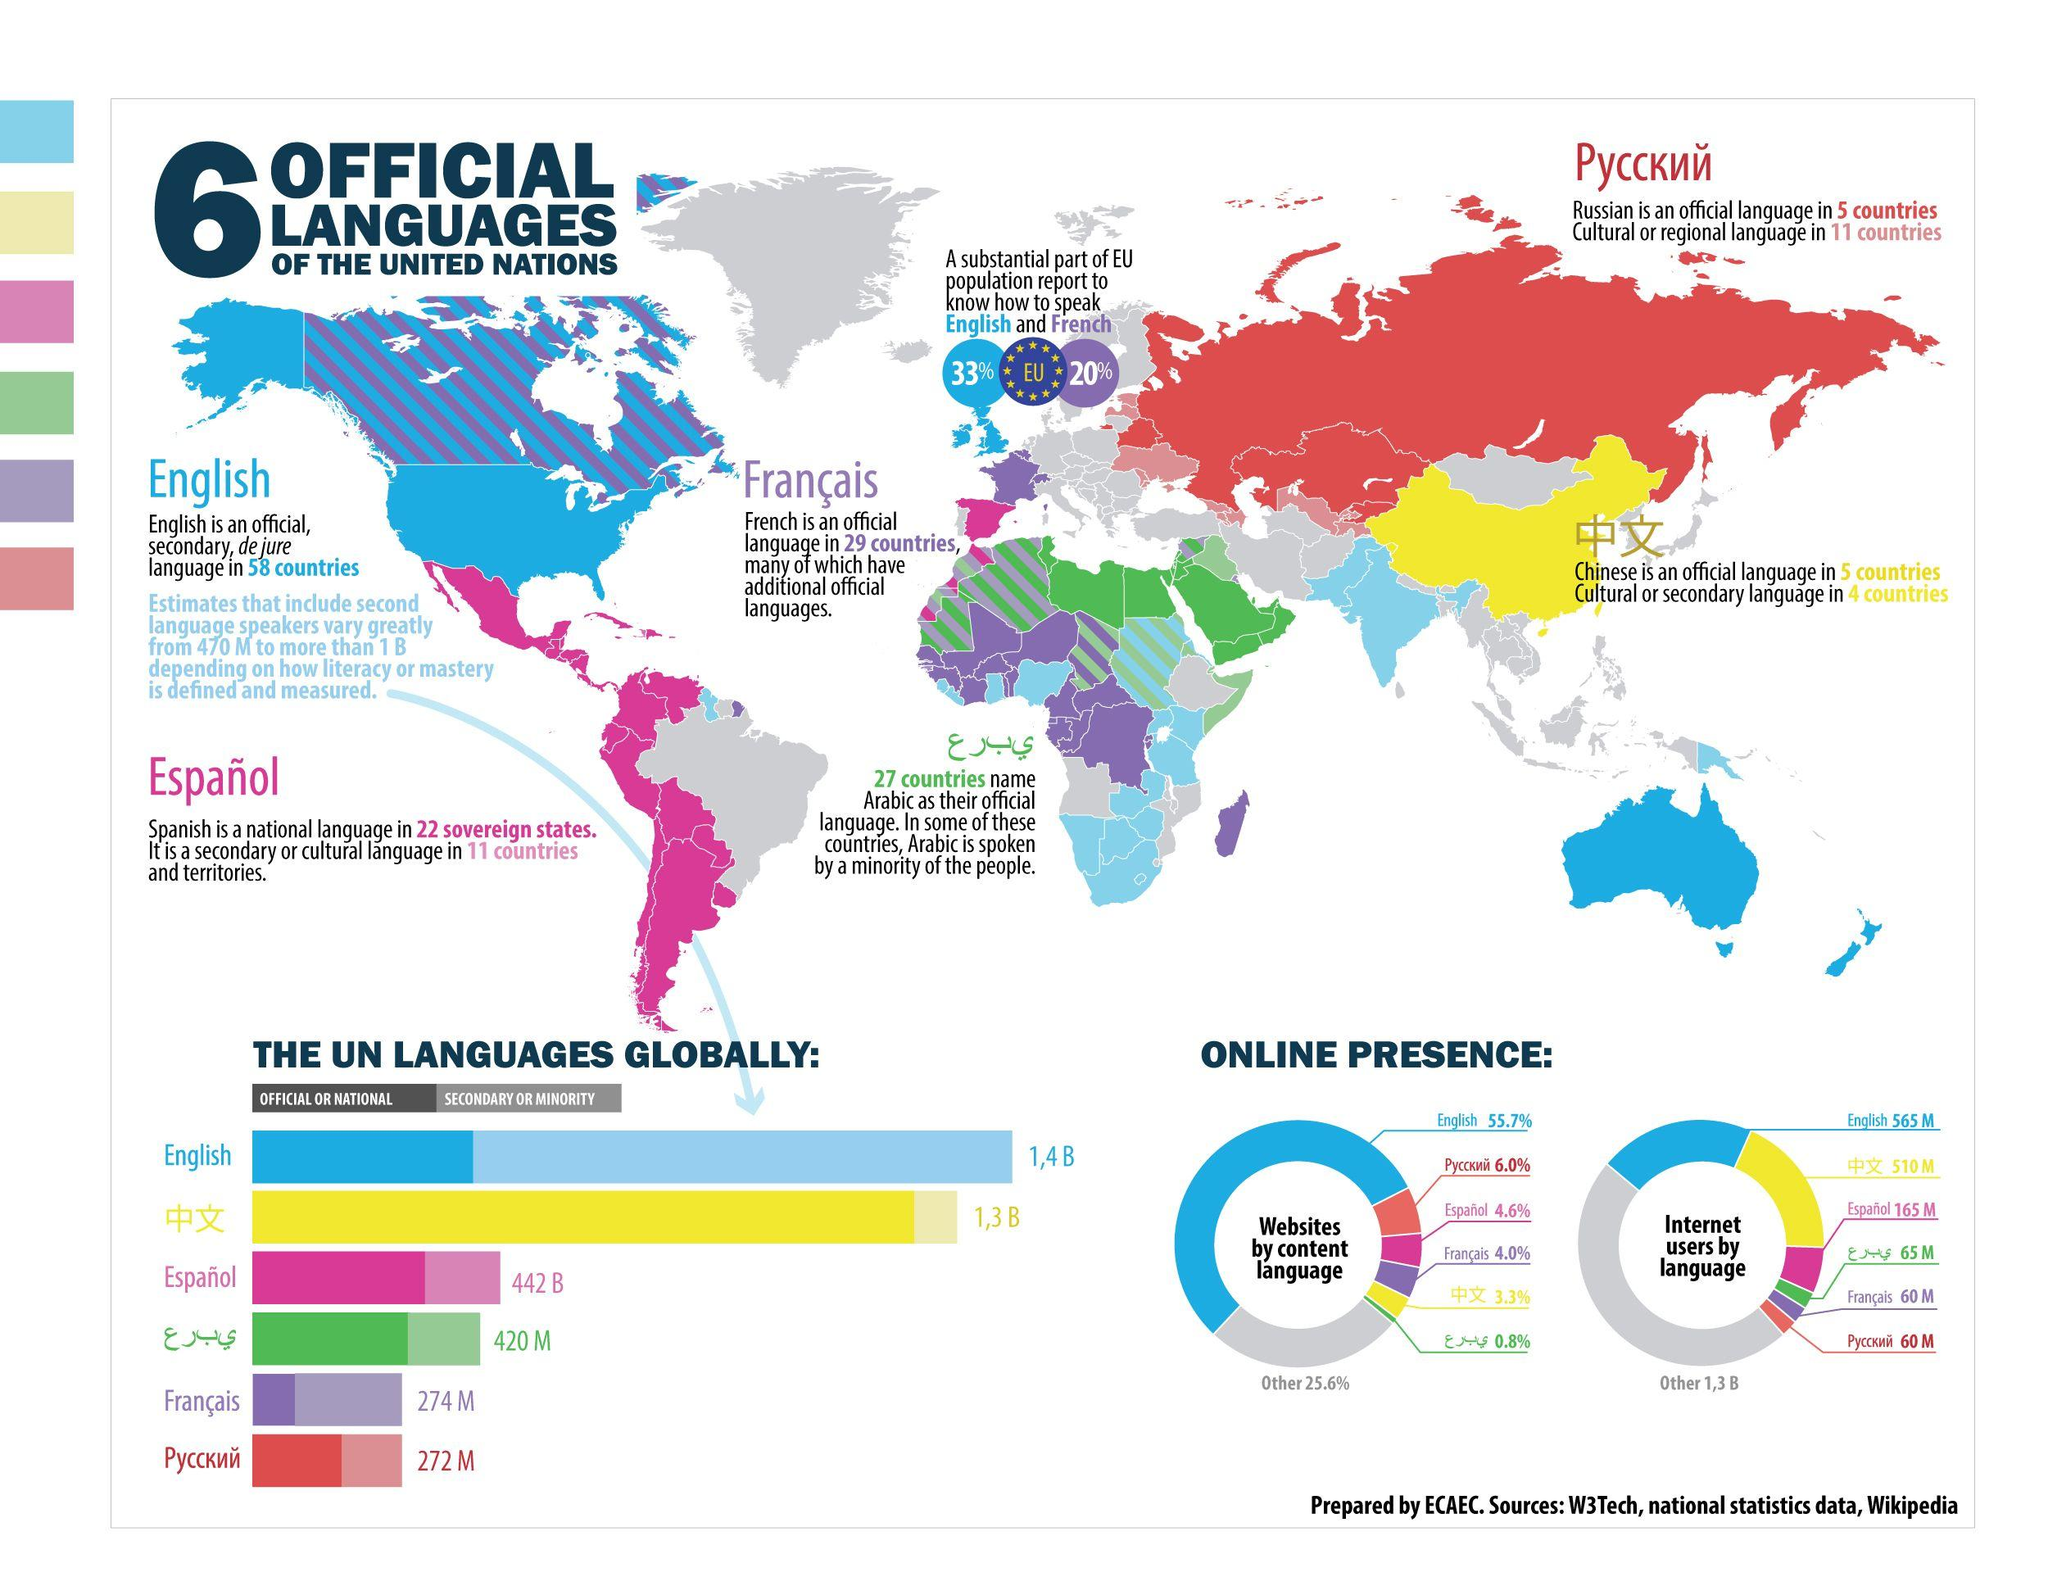List a handful of essential elements in this visual. French is the second most spoken language in the world. English is the most commonly spoken secondary language. 13% of the EU population speaks English more than French. There are approximately 60 million internet users in Russia, making up a significant portion of the country's population. A recent study found that only 4.6% of websites use Spanish content. 